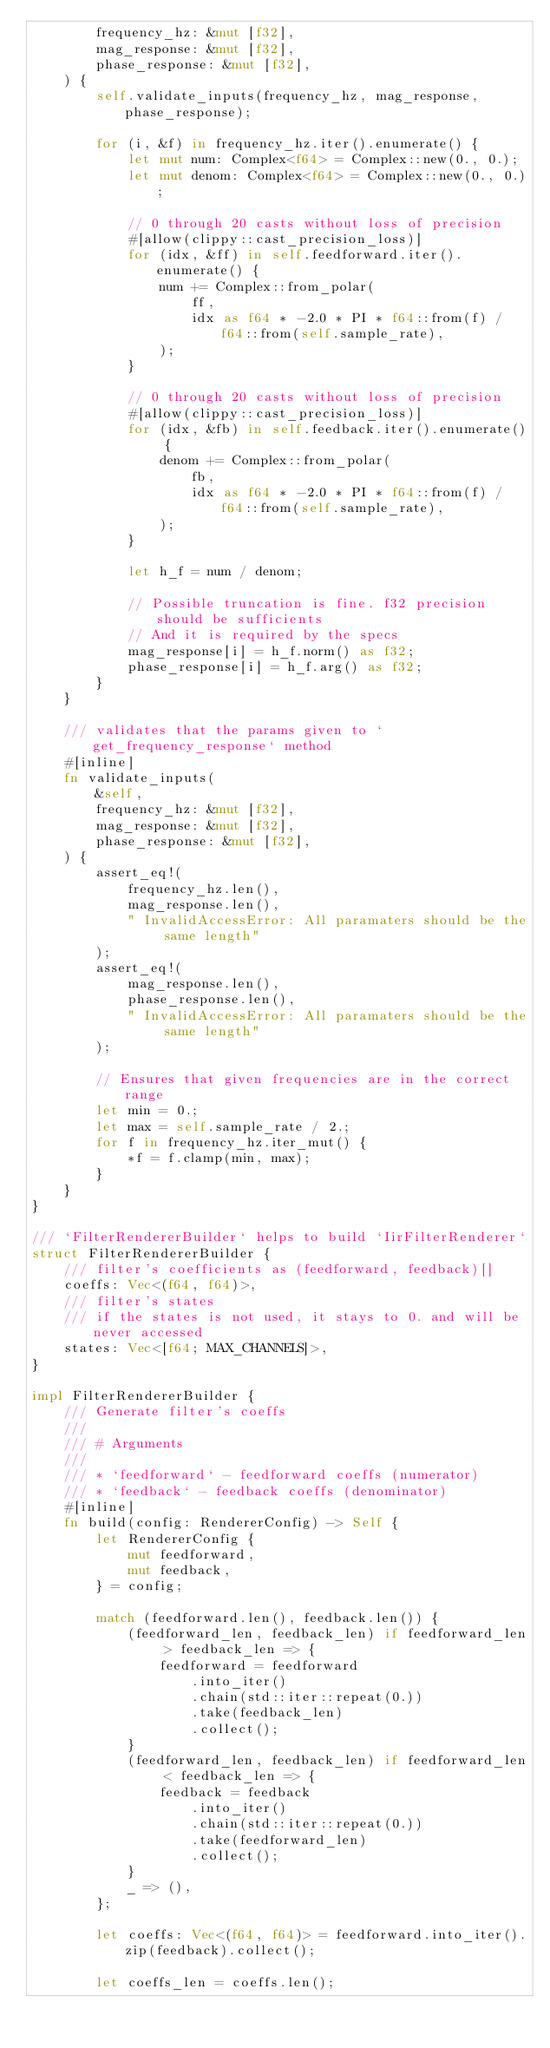Convert code to text. <code><loc_0><loc_0><loc_500><loc_500><_Rust_>        frequency_hz: &mut [f32],
        mag_response: &mut [f32],
        phase_response: &mut [f32],
    ) {
        self.validate_inputs(frequency_hz, mag_response, phase_response);

        for (i, &f) in frequency_hz.iter().enumerate() {
            let mut num: Complex<f64> = Complex::new(0., 0.);
            let mut denom: Complex<f64> = Complex::new(0., 0.);

            // 0 through 20 casts without loss of precision
            #[allow(clippy::cast_precision_loss)]
            for (idx, &ff) in self.feedforward.iter().enumerate() {
                num += Complex::from_polar(
                    ff,
                    idx as f64 * -2.0 * PI * f64::from(f) / f64::from(self.sample_rate),
                );
            }

            // 0 through 20 casts without loss of precision
            #[allow(clippy::cast_precision_loss)]
            for (idx, &fb) in self.feedback.iter().enumerate() {
                denom += Complex::from_polar(
                    fb,
                    idx as f64 * -2.0 * PI * f64::from(f) / f64::from(self.sample_rate),
                );
            }

            let h_f = num / denom;

            // Possible truncation is fine. f32 precision should be sufficients
            // And it is required by the specs
            mag_response[i] = h_f.norm() as f32;
            phase_response[i] = h_f.arg() as f32;
        }
    }

    /// validates that the params given to `get_frequency_response` method
    #[inline]
    fn validate_inputs(
        &self,
        frequency_hz: &mut [f32],
        mag_response: &mut [f32],
        phase_response: &mut [f32],
    ) {
        assert_eq!(
            frequency_hz.len(),
            mag_response.len(),
            " InvalidAccessError: All paramaters should be the same length"
        );
        assert_eq!(
            mag_response.len(),
            phase_response.len(),
            " InvalidAccessError: All paramaters should be the same length"
        );

        // Ensures that given frequencies are in the correct range
        let min = 0.;
        let max = self.sample_rate / 2.;
        for f in frequency_hz.iter_mut() {
            *f = f.clamp(min, max);
        }
    }
}

/// `FilterRendererBuilder` helps to build `IirFilterRenderer`
struct FilterRendererBuilder {
    /// filter's coefficients as (feedforward, feedback)[]
    coeffs: Vec<(f64, f64)>,
    /// filter's states
    /// if the states is not used, it stays to 0. and will be never accessed
    states: Vec<[f64; MAX_CHANNELS]>,
}

impl FilterRendererBuilder {
    /// Generate filter's coeffs
    ///
    /// # Arguments
    ///
    /// * `feedforward` - feedforward coeffs (numerator)
    /// * `feedback` - feedback coeffs (denominator)
    #[inline]
    fn build(config: RendererConfig) -> Self {
        let RendererConfig {
            mut feedforward,
            mut feedback,
        } = config;

        match (feedforward.len(), feedback.len()) {
            (feedforward_len, feedback_len) if feedforward_len > feedback_len => {
                feedforward = feedforward
                    .into_iter()
                    .chain(std::iter::repeat(0.))
                    .take(feedback_len)
                    .collect();
            }
            (feedforward_len, feedback_len) if feedforward_len < feedback_len => {
                feedback = feedback
                    .into_iter()
                    .chain(std::iter::repeat(0.))
                    .take(feedforward_len)
                    .collect();
            }
            _ => (),
        };

        let coeffs: Vec<(f64, f64)> = feedforward.into_iter().zip(feedback).collect();

        let coeffs_len = coeffs.len();</code> 